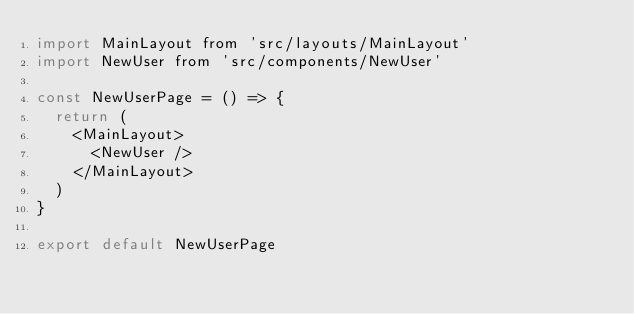Convert code to text. <code><loc_0><loc_0><loc_500><loc_500><_JavaScript_>import MainLayout from 'src/layouts/MainLayout'
import NewUser from 'src/components/NewUser'

const NewUserPage = () => {
  return (
    <MainLayout>
      <NewUser />
    </MainLayout>
  )
}

export default NewUserPage
</code> 